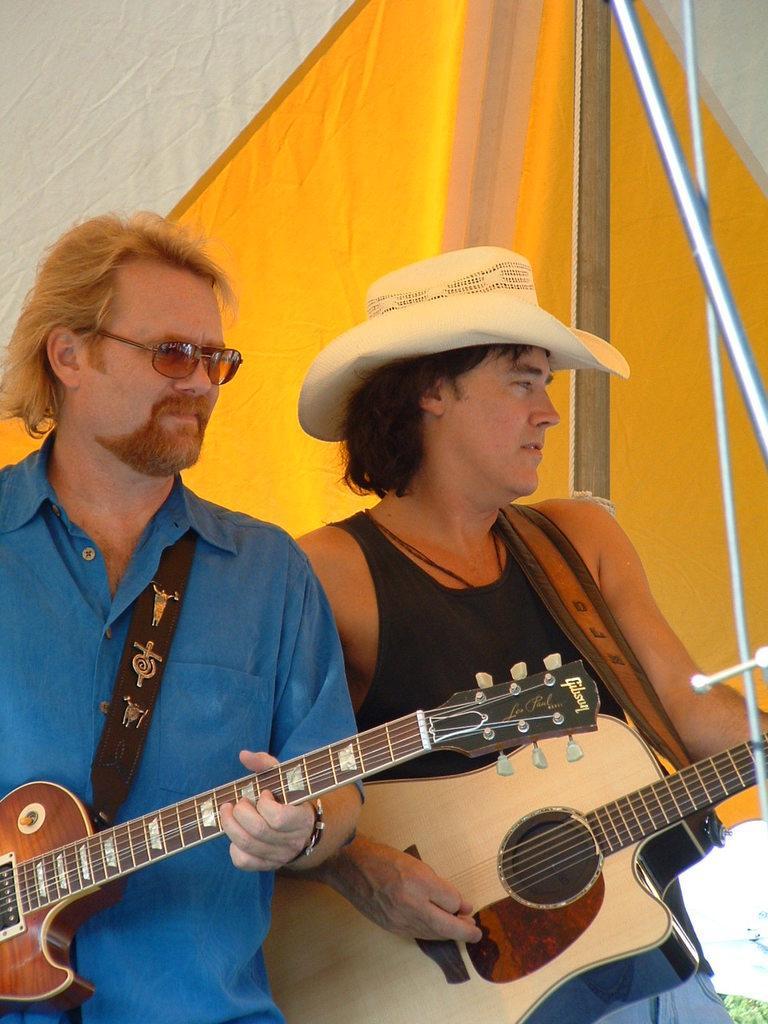Could you give a brief overview of what you see in this image? In this picture we can see two persons they are in the tent, and they are playing guitar, the right side person is wearing a cap. 